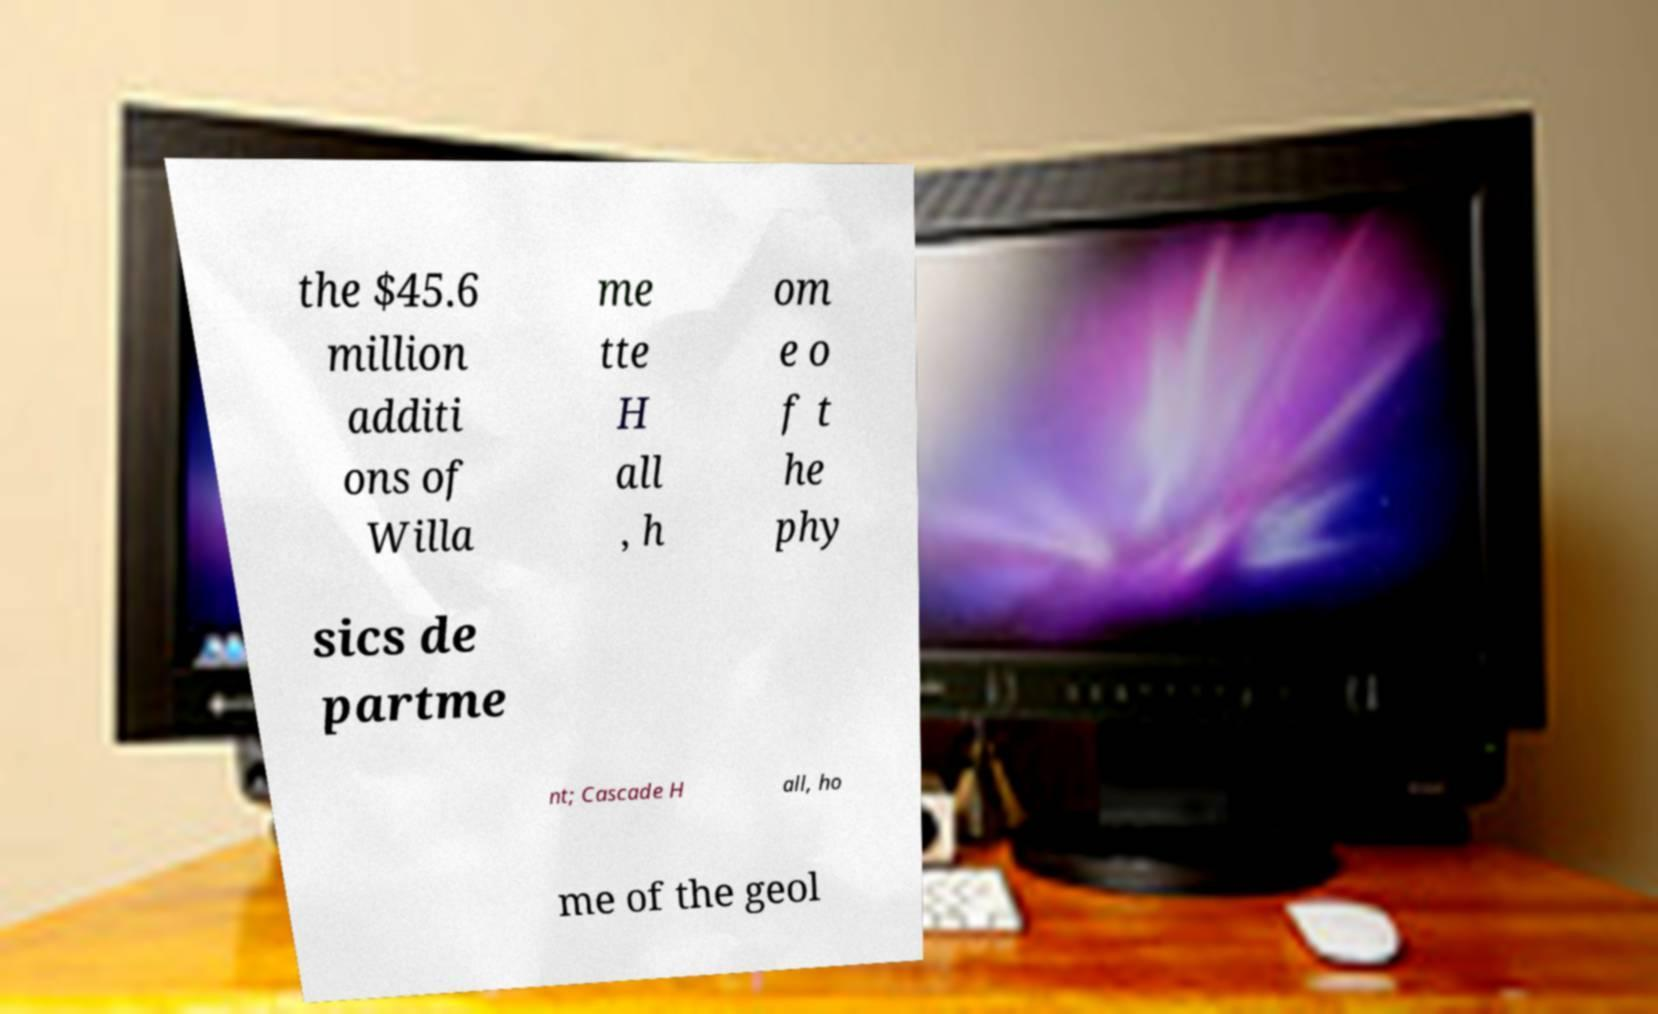Could you extract and type out the text from this image? the $45.6 million additi ons of Willa me tte H all , h om e o f t he phy sics de partme nt; Cascade H all, ho me of the geol 